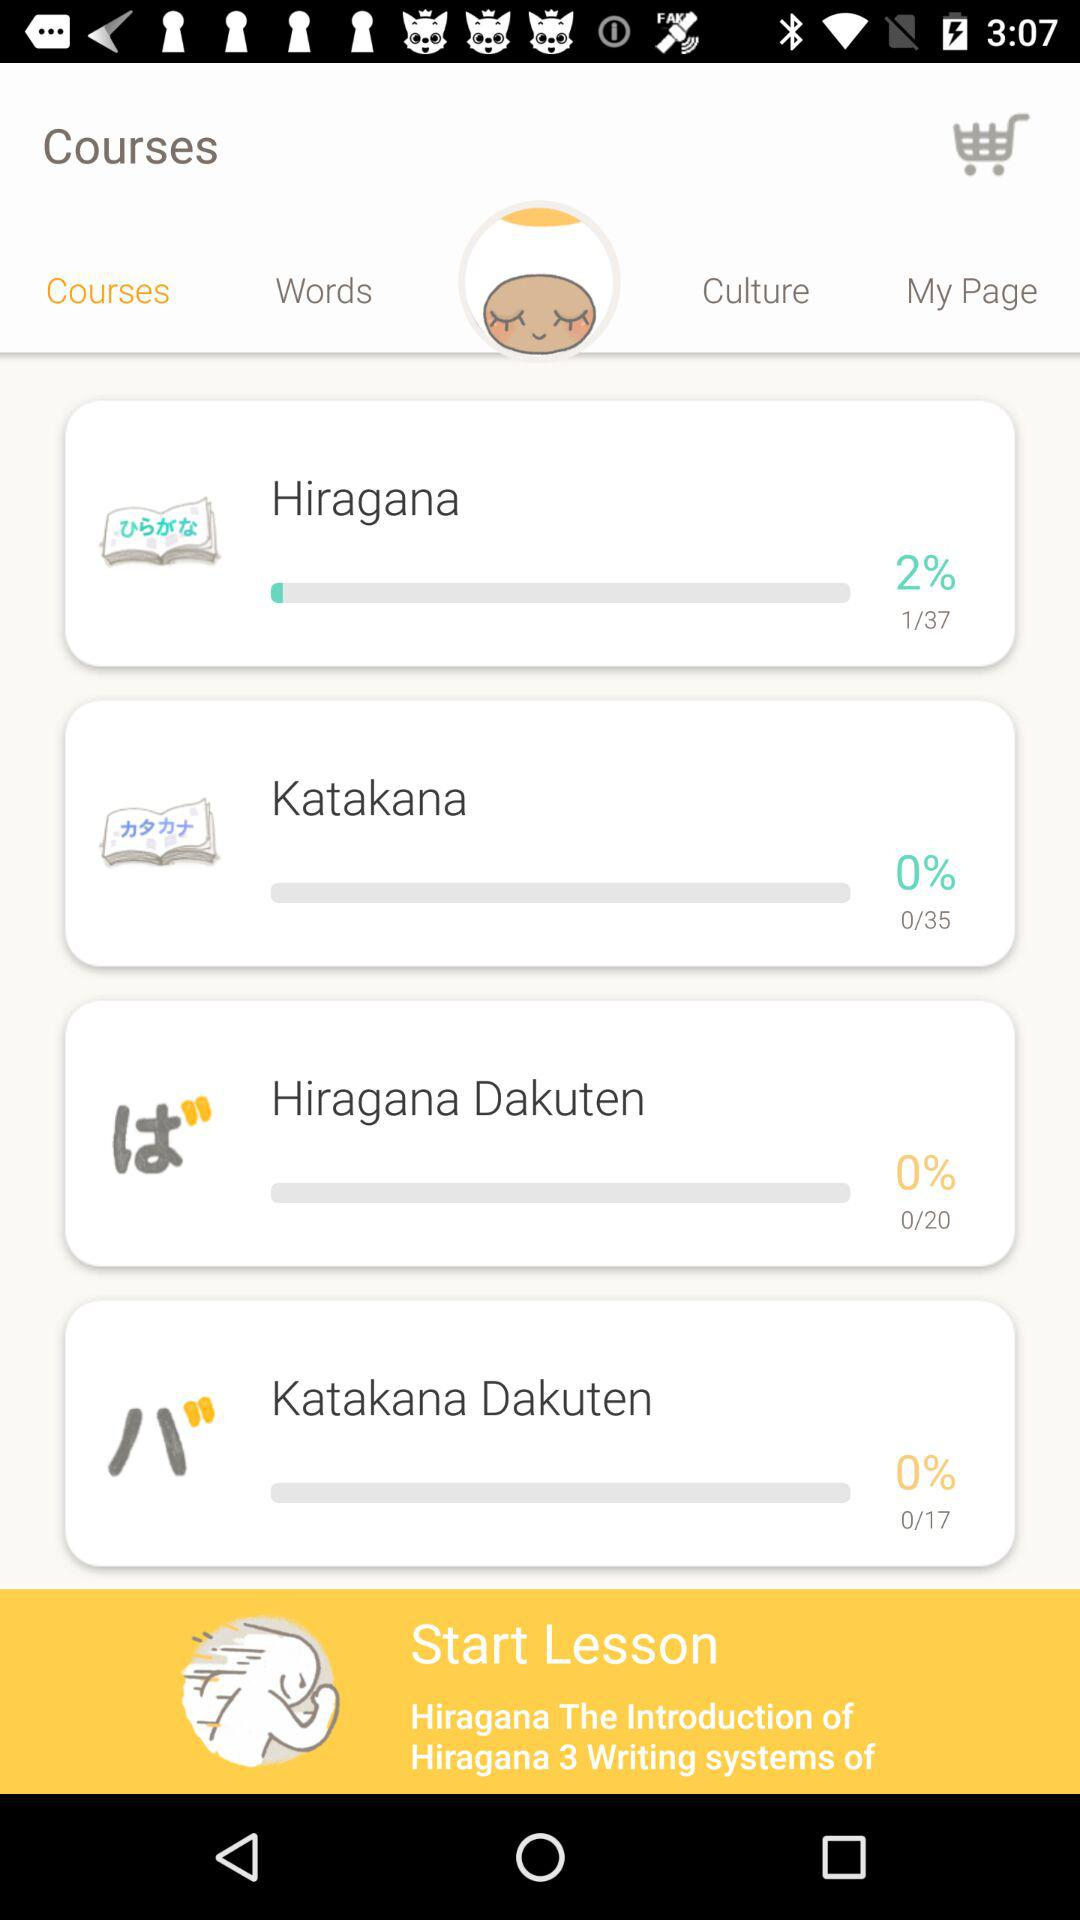How many more lessons are there for Hiragana than Katakana?
Answer the question using a single word or phrase. 2 